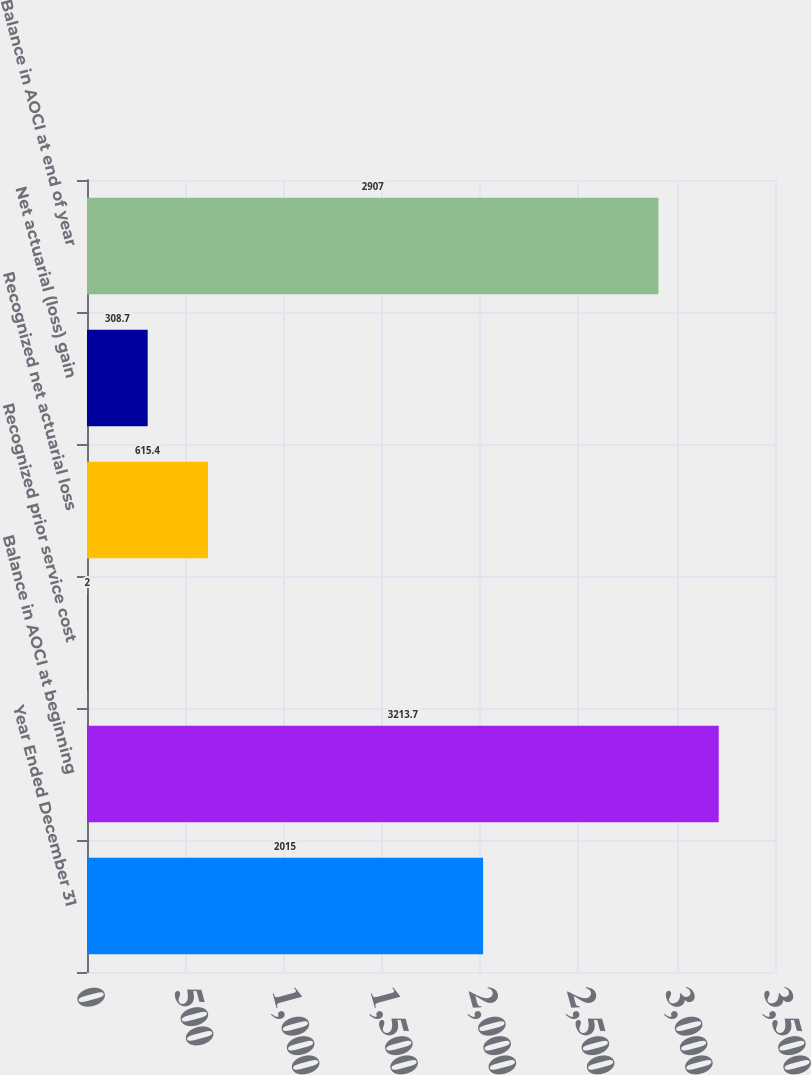Convert chart to OTSL. <chart><loc_0><loc_0><loc_500><loc_500><bar_chart><fcel>Year Ended December 31<fcel>Balance in AOCI at beginning<fcel>Recognized prior service cost<fcel>Recognized net actuarial loss<fcel>Net actuarial (loss) gain<fcel>Balance in AOCI at end of year<nl><fcel>2015<fcel>3213.7<fcel>2<fcel>615.4<fcel>308.7<fcel>2907<nl></chart> 